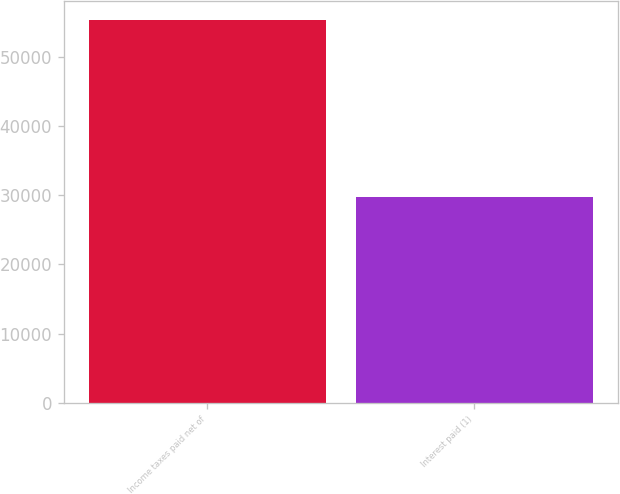Convert chart to OTSL. <chart><loc_0><loc_0><loc_500><loc_500><bar_chart><fcel>Income taxes paid net of<fcel>Interest paid (1)<nl><fcel>55218<fcel>29677<nl></chart> 